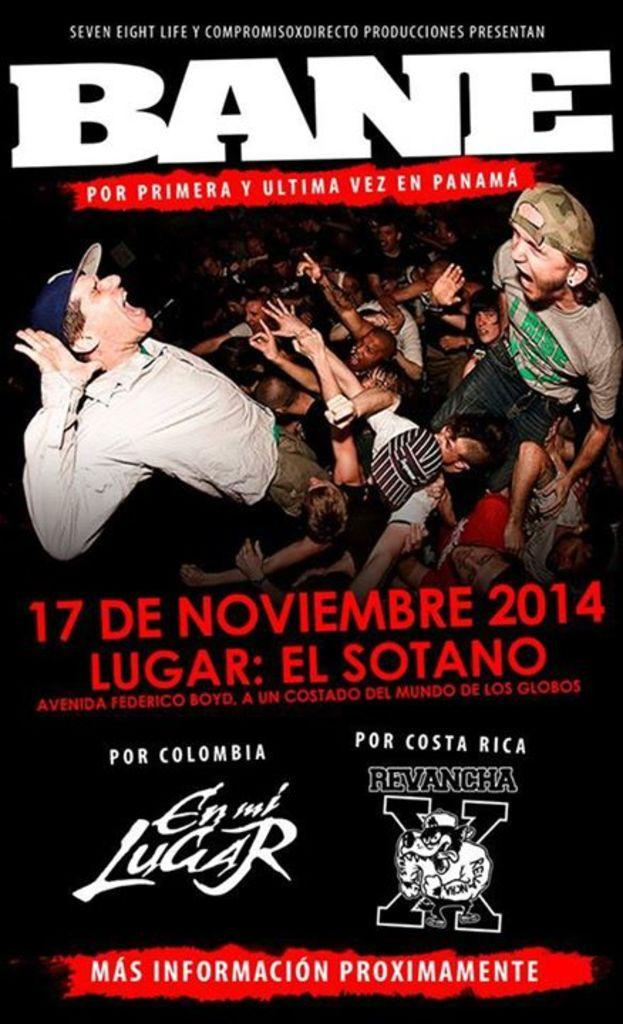What is present in the image that contains visuals and text? There is a poster in the image that contains pictures and text. Can you describe the content of the poster? The poster contains pictures and text, but the specific content cannot be determined from the provided facts. How many babies are shown playing with steel objects in the poster? There is no mention of babies or steel objects in the image or the provided facts, so this question cannot be answered. 